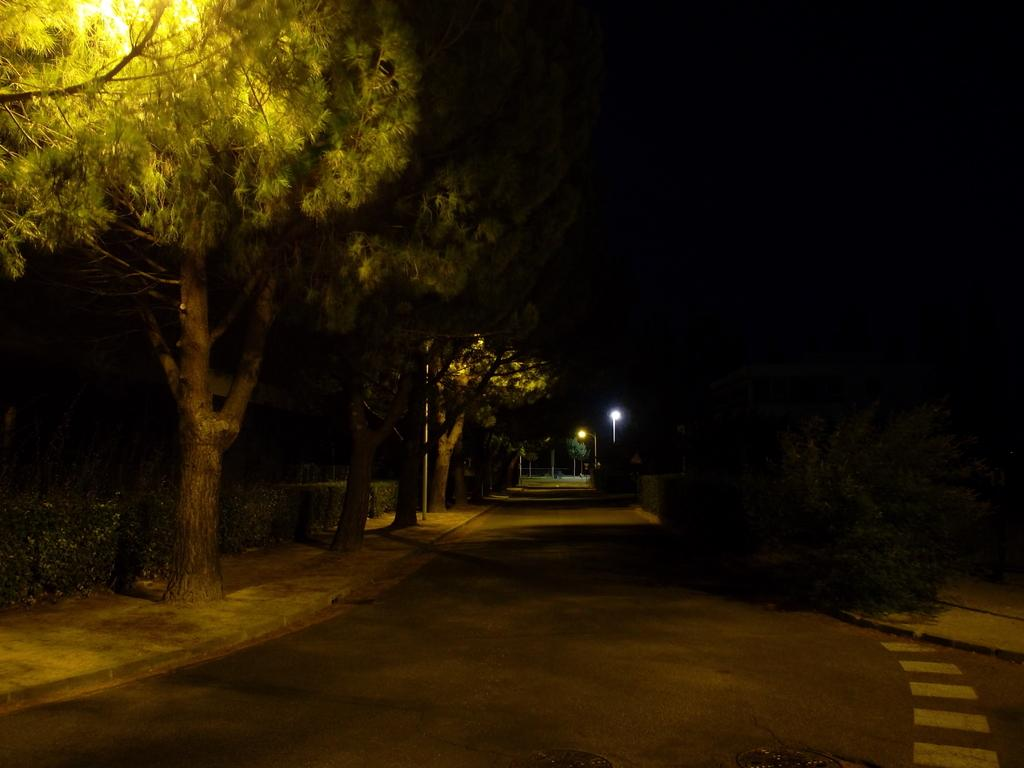What is the main feature of the image? There is a road in the image. What can be seen alongside the road? There are trees in the image. What is visible in the background of the image? There are street lights in the background of the image. What type of leather can be seen hanging from the trees in the image? There is no leather present in the image; it features a road, trees, and street lights. 